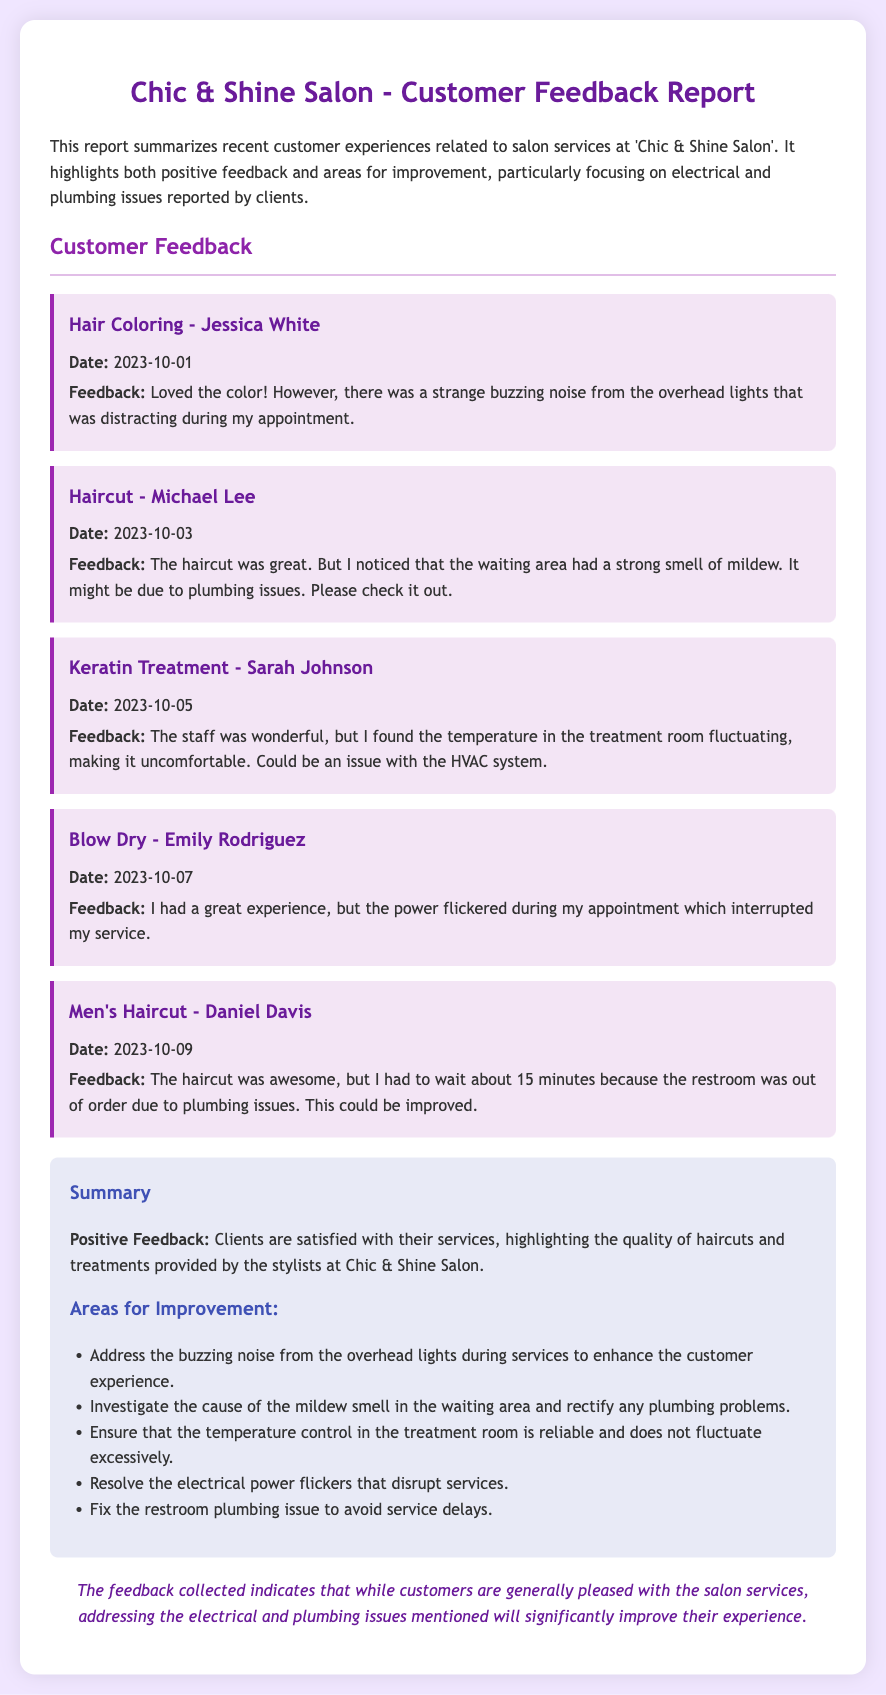What date did Jessica White provide her feedback? Jessica White provided her feedback on October 1, 2023, as indicated in the document.
Answer: 2023-10-01 What was the feedback from Michael Lee? Michael Lee mentioned that the haircut was great but noted a strong mildew smell in the waiting area, which may indicate plumbing issues.
Answer: The haircut was great; strong smell of mildew Which service received positive feedback about the staff? The feedback for the Keratin Treatment mentioned that the staff was wonderful.
Answer: Keratin Treatment What issue was reported by Emily Rodriguez during her appointment? Emily Rodriguez reported that the power flickered during her appointment, which interrupted her service.
Answer: Power flickered What are two areas mentioned for improvement in the summary? The summary lists multiple areas for improvement, including the buzzing noise from lights and the mildew smell in the waiting area.
Answer: Buzzing noise, mildew smell How many days elapsed between Michael Lee's feedback and Jessica White's feedback? Michael Lee's feedback was on October 3, 2023, and Jessica White's was on October 1, 2023, so two days elapsed.
Answer: 2 days Was there a plumbing issue noted related to the restroom? Yes, Daniel Davis mentioned that the restroom was out of order due to plumbing issues.
Answer: Yes What type of report is this document? This document is a customer feedback report summarizing experiences related to salon services.
Answer: Customer feedback report Which client's feedback indicated discomfort due to temperature fluctuations? Sarah Johnson indicated discomfort due to temperature fluctuations in the treatment room.
Answer: Sarah Johnson 